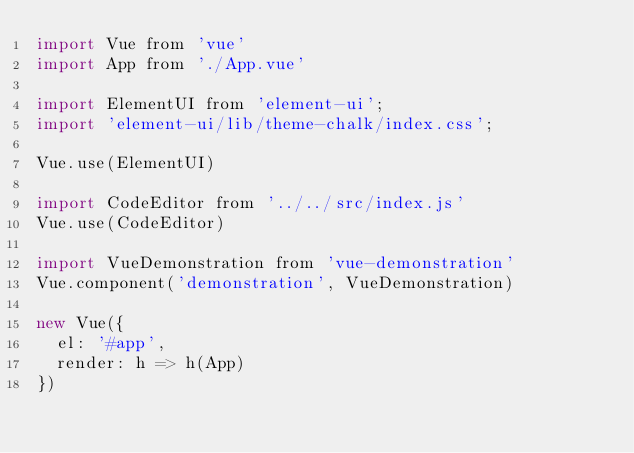Convert code to text. <code><loc_0><loc_0><loc_500><loc_500><_JavaScript_>import Vue from 'vue'
import App from './App.vue'

import ElementUI from 'element-ui';
import 'element-ui/lib/theme-chalk/index.css';

Vue.use(ElementUI)

import CodeEditor from '../../src/index.js'
Vue.use(CodeEditor)

import VueDemonstration from 'vue-demonstration'
Vue.component('demonstration', VueDemonstration)

new Vue({
  el: '#app',
  render: h => h(App)
})
</code> 